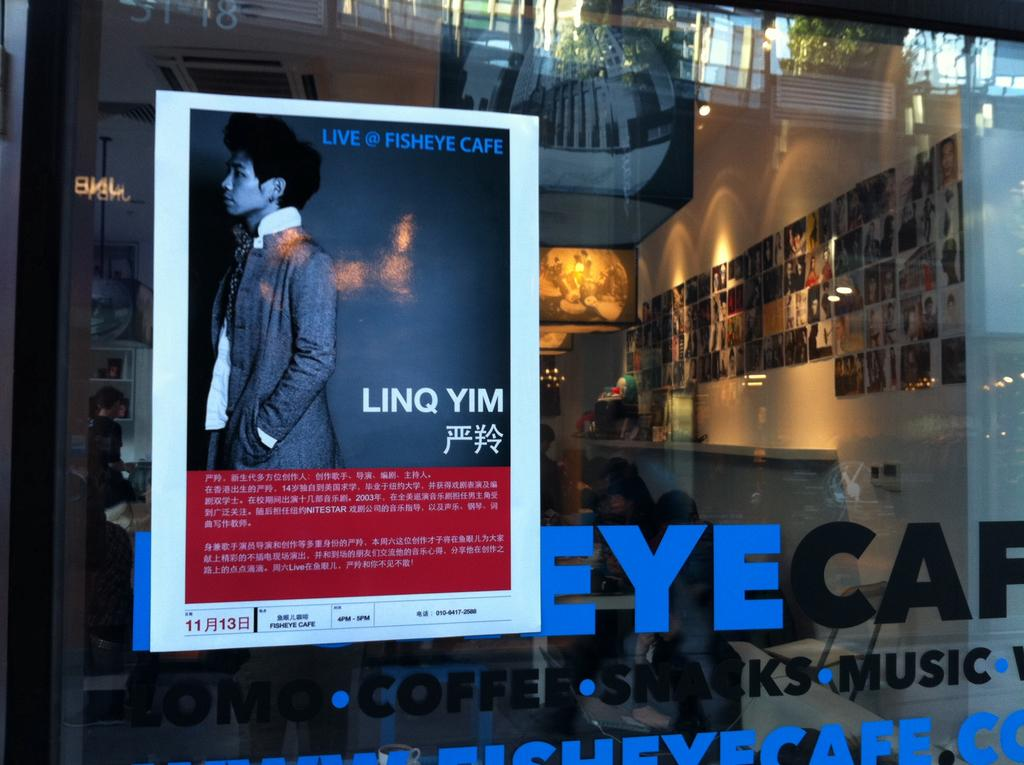<image>
Provide a brief description of the given image. A poster advertising that Linq Yim is going to be at the Fisheye Cafe is on the window on that cafe. 